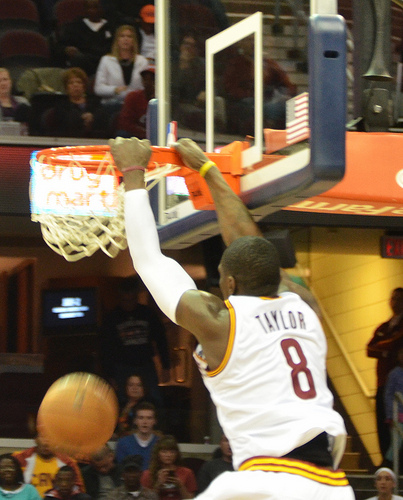<image>
Is the spectator above the basket? Yes. The spectator is positioned above the basket in the vertical space, higher up in the scene. 